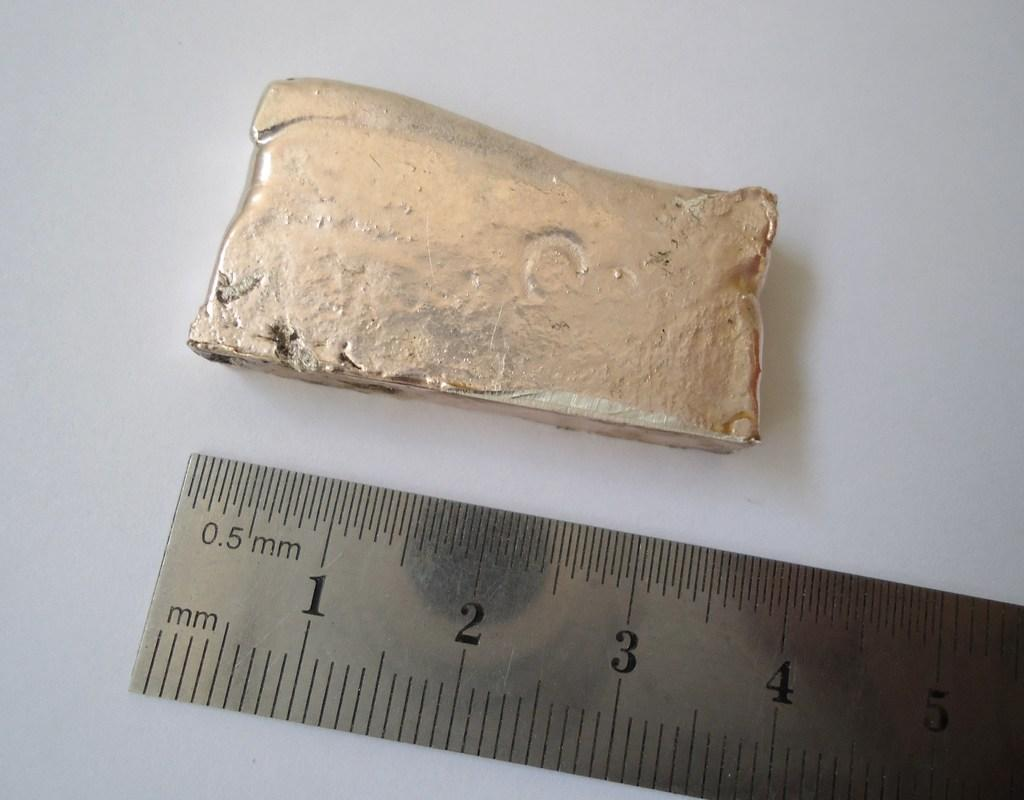<image>
Describe the image concisely. A metal ruler sits along side an unknown cream object measuring 4 inches in length. 